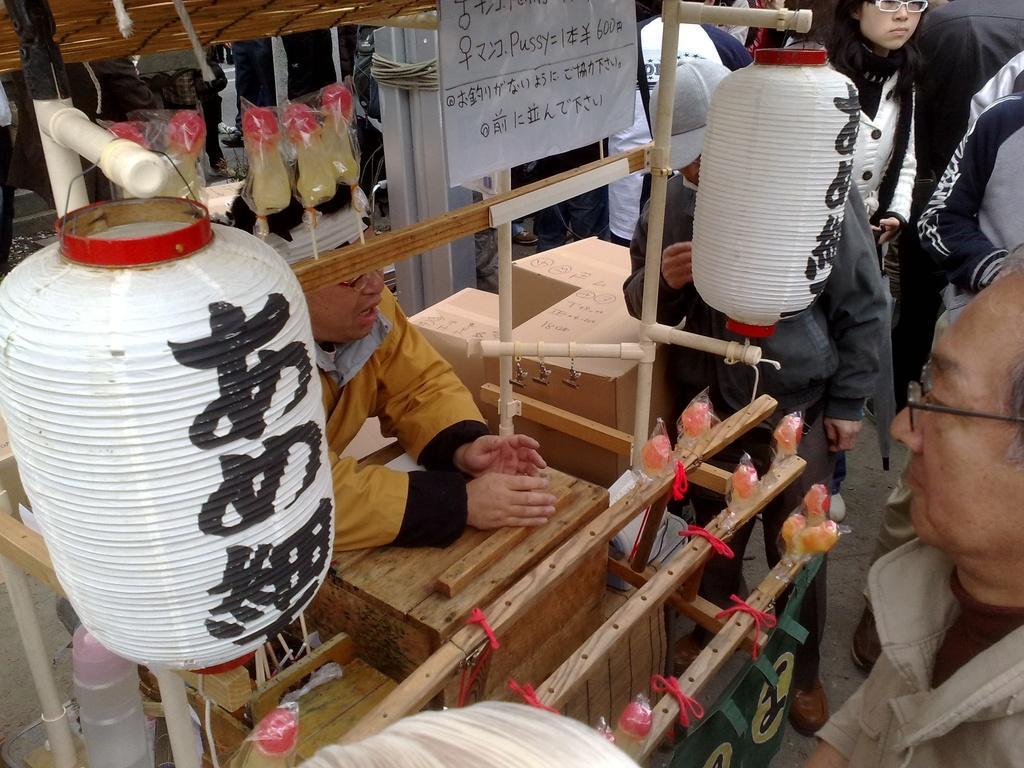Describe this image in one or two sentences. In this image we can see a few people standing, there are some wooden objects and also the other objects. 